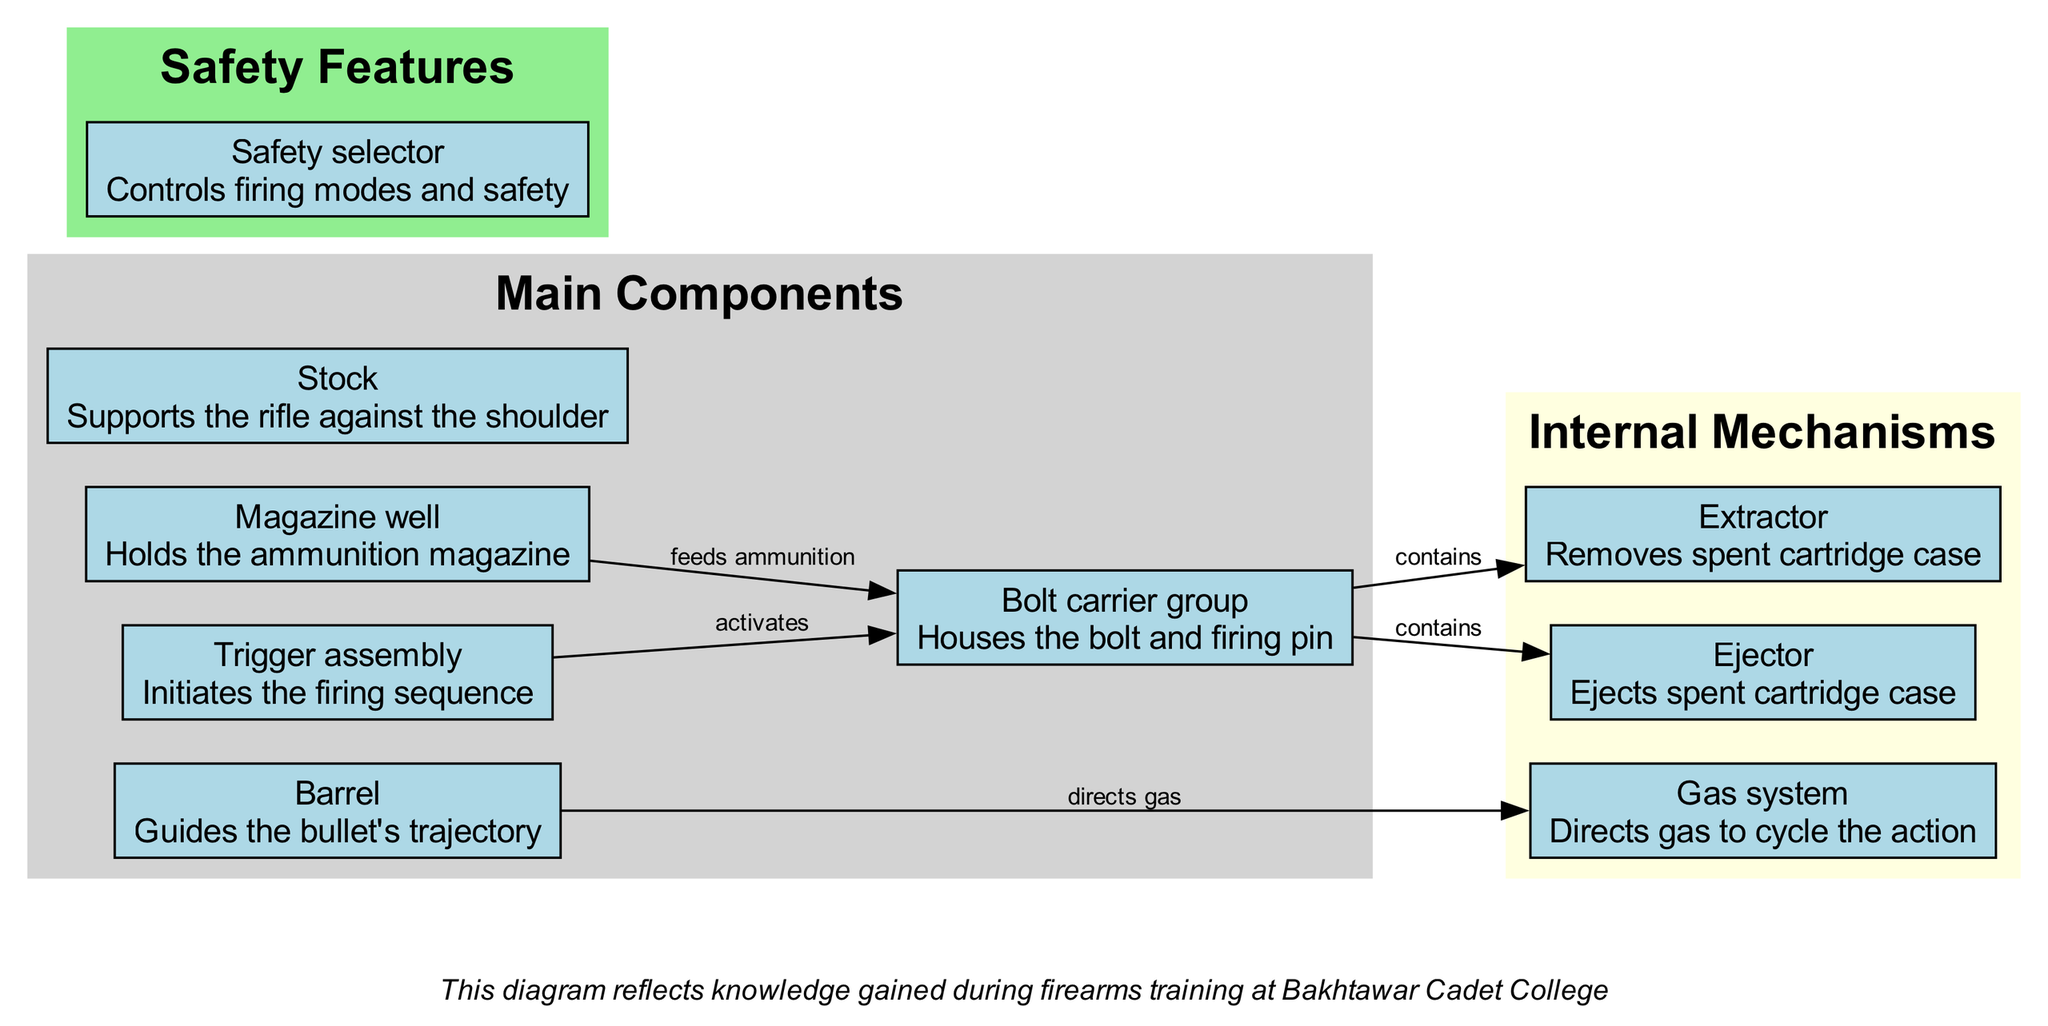What are the main components of the rifle? The diagram includes five main components: Barrel, Bolt carrier group, Trigger assembly, Magazine well, and Stock. These components are clearly labeled and organized in a distinct section.
Answer: Barrel, Bolt carrier group, Trigger assembly, Magazine well, Stock How many internal mechanisms are labeled in the diagram? There are three internal mechanisms listed: Gas system, Extractor, and Ejector. This can be confirmed by counting the items in the internal mechanisms subgraph.
Answer: 3 What is the function of the Trigger assembly? The diagram specifies that the Trigger assembly initiates the firing sequence. This description is provided directly under the labeled component.
Answer: Initiates the firing sequence Which component contains both the Extractor and Ejector? The diagram indicates that the Bolt carrier group contains both the Extractor and Ejector, as shown by the connecting lines from the Bolt carrier group to these mechanisms.
Answer: Bolt carrier group How does the Barrel relate to the Gas system? The diagram shows a directed edge from the Barrel to the Gas system, specifying that the Barrel directs gas to cycle the action. This explains their functional relationship.
Answer: Directs gas What is the role of the Safety selector? The Safety selector is described in the diagram as controlling firing modes and safety, indicating its purpose in the rifle's operation.
Answer: Controls firing modes and safety How many components are there that support the rifle against the shoulder? The diagram identifies one component meant for support against the shoulder, which is the Stock. This is explicitly stated in its description.
Answer: 1 What initiates the firing sequence in this rifle? According to the diagram, the Trigger assembly is responsible for initiating the firing sequence. This direct correlation is clearly indicated in the labeled parts.
Answer: Trigger assembly What feature would prevent the rifle from accidentally firing? The Safety selector serves this purpose by controlling firing modes and ensuring safety, as mentioned in the diagram's safety features section.
Answer: Safety selector 